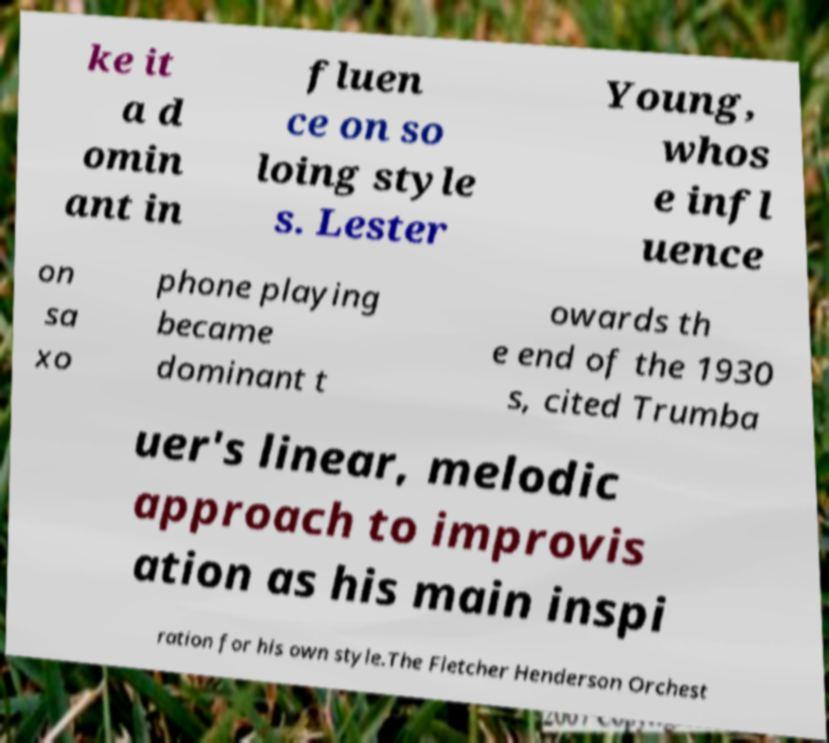Can you read and provide the text displayed in the image?This photo seems to have some interesting text. Can you extract and type it out for me? ke it a d omin ant in fluen ce on so loing style s. Lester Young, whos e infl uence on sa xo phone playing became dominant t owards th e end of the 1930 s, cited Trumba uer's linear, melodic approach to improvis ation as his main inspi ration for his own style.The Fletcher Henderson Orchest 